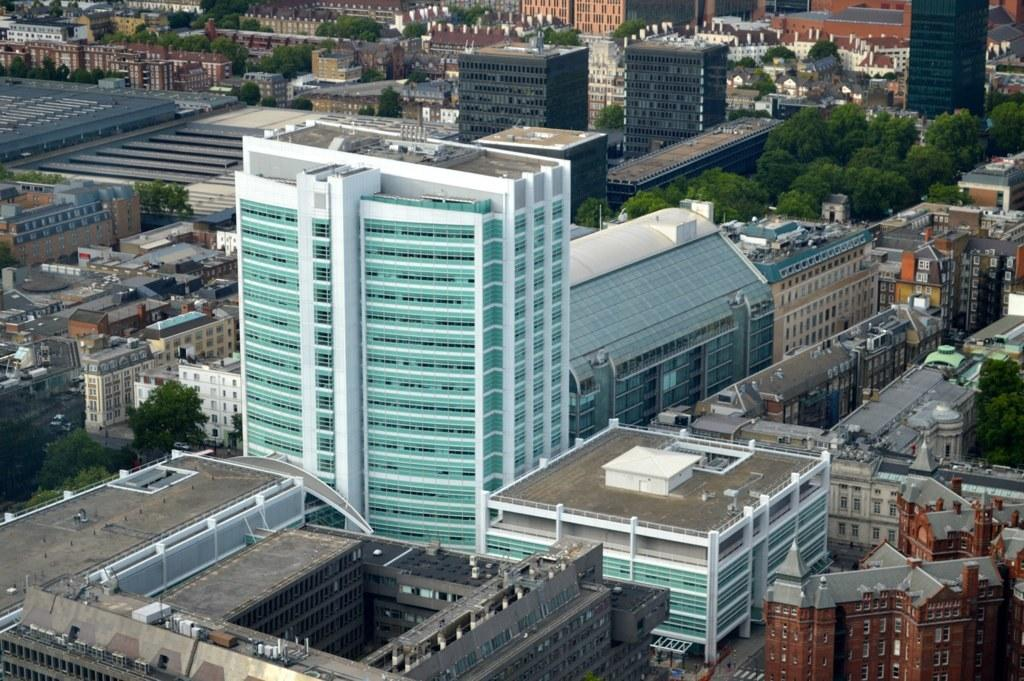What is located in the center of the image? There are buildings, towers, trees, windows, and a few other objects in the center of the image. Can you describe the buildings in the image? The buildings in the image have towers and windows. What type of natural elements can be seen in the center of the image? There are trees in the center of the image. How many different types of objects can be seen in the center of the image? There are at least five different types of objects in the center of the image: buildings, towers, trees, windows, and other objects. What type of pollution can be seen in the image? There is no pollution visible in the image. Can you describe the rat that is climbing the tree in the image? There is no rat present in the image; it only features buildings, towers, trees, windows, and other objects. 